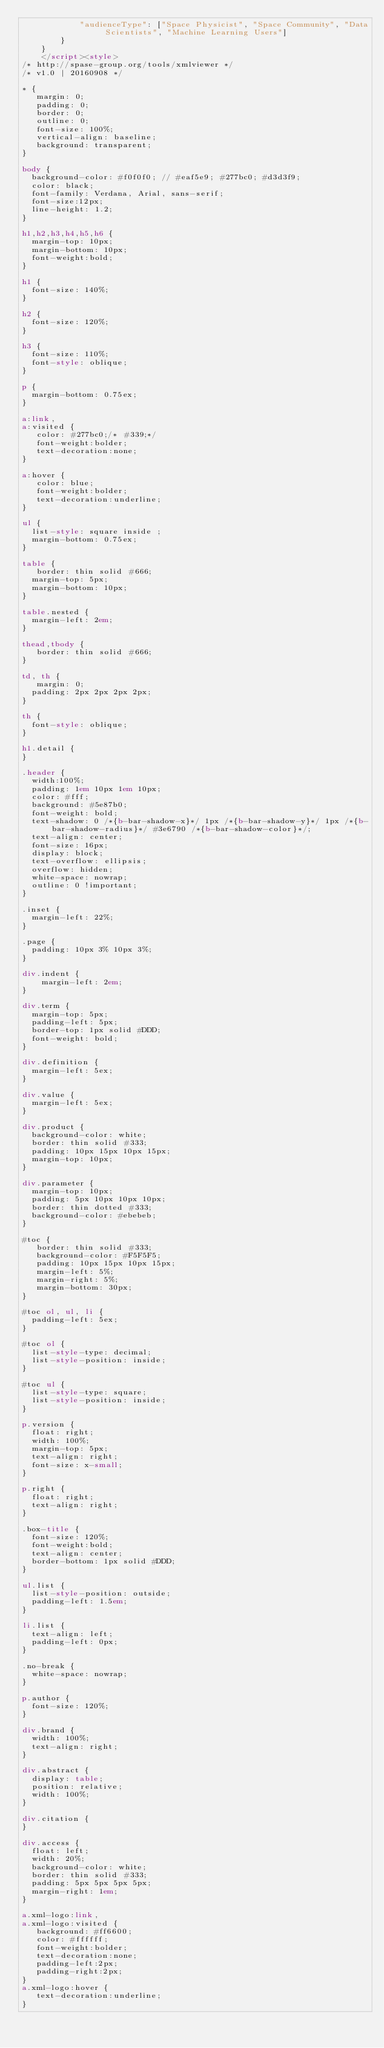<code> <loc_0><loc_0><loc_500><loc_500><_HTML_>            "audienceType": ["Space Physicist", "Space Community", "Data Scientists", "Machine Learning Users"]
        }
	  }
	  </script><style>
/* http://spase-group.org/tools/xmlviewer */
/* v1.0 | 20160908 */

* {
   margin: 0;
   padding: 0;
   border: 0;
   outline: 0;
   font-size: 100%;
   vertical-align: baseline;
   background: transparent;
}

body {
	background-color: #f0f0f0; // #eaf5e9; #277bc0; #d3d3f9;
	color: black;
	font-family: Verdana, Arial, sans-serif; 
	font-size:12px; 
	line-height: 1.2;
}
 
h1,h2,h3,h4,h5,h6 {
	margin-top: 10px;
	margin-bottom: 10px;
	font-weight:bold;
}

h1 {
	font-size: 140%;
}

h2 {
	font-size: 120%;
}

h3 {
	font-size: 110%;
	font-style: oblique;
}

p {
	margin-bottom: 0.75ex;
}

a:link,
a:visited {
   color: #277bc0;/* #339;*/
   font-weight:bolder; 
   text-decoration:none; 
}

a:hover {
   color: blue;
   font-weight:bolder; 
   text-decoration:underline; 
}

ul {
	list-style: square inside ;
	margin-bottom: 0.75ex;
}

table {
   border: thin solid #666;
	margin-top: 5px;
	margin-bottom: 10px;
}

table.nested {
	margin-left: 2em;
}

thead,tbody {
   border: thin solid #666;
}

td, th {
   margin: 0;
	padding: 2px 2px 2px 2px;
}

th {
	font-style: oblique;
}

h1.detail {
}

.header {
	width:100%;
	padding: 1em 10px 1em 10px;
	color: #fff;
	background: #5e87b0;
	font-weight: bold;
	text-shadow: 0 /*{b-bar-shadow-x}*/ 1px /*{b-bar-shadow-y}*/ 1px /*{b-bar-shadow-radius}*/ #3e6790 /*{b-bar-shadow-color}*/;
	text-align: center;
	font-size: 16px;
	display: block;
	text-overflow: ellipsis;
	overflow: hidden;
	white-space: nowrap;
	outline: 0 !important;
}

.inset {
	margin-left: 22%;
}

.page {
	padding: 10px 3% 10px 3%;
}

div.indent {
    margin-left: 2em;
}

div.term {
	margin-top: 5px;
	padding-left: 5px;
	border-top: 1px solid #DDD;
	font-weight: bold;
}

div.definition {
	margin-left: 5ex;
}

div.value {
	margin-left: 5ex;
}

div.product {
	background-color: white;
	border: thin solid #333;
	padding: 10px 15px 10px 15px;
	margin-top: 10px;
}

div.parameter {
	margin-top: 10px;
	padding: 5px 10px 10px 10px;
	border: thin dotted #333;
	background-color: #ebebeb;
}

#toc {
   border: thin solid #333;
   background-color: #F5F5F5; 
   padding: 10px 15px 10px 15px;
   margin-left: 5%;
   margin-right: 5%;
   margin-bottom: 30px;
}

#toc ol, ul, li {
	padding-left: 5ex;
}

#toc ol {
	list-style-type: decimal;
	list-style-position: inside; 
}

#toc ul {
	list-style-type: square;
	list-style-position: inside; 
}

p.version {
  float: right;
  width: 100%;
  margin-top: 5px;
  text-align: right;
  font-size: x-small;
}

p.right {
  float: right;
  text-align: right;
}

.box-title {
	font-size: 120%;
	font-weight:bold;
	text-align: center;
	border-bottom: 1px solid #DDD;
}

ul.list {
	list-style-position: outside;
	padding-left: 1.5em;
}

li.list {
	text-align: left;
	padding-left: 0px;
}

.no-break {
	white-space: nowrap;
}

p.author {
	font-size: 120%;
}

div.brand {
	width: 100%;
	text-align: right;
}

div.abstract {
	display: table;
	position: relative;
	width: 100%;
}

div.citation {
}

div.access {
	float: left;
	width: 20%;
	background-color: white;
	border: thin solid #333;
	padding: 5px 5px 5px 5px;
	margin-right: 1em;
}

a.xml-logo:link,
a.xml-logo:visited {
   background: #ff6600;
   color: #ffffff;
   font-weight:bolder; 
   text-decoration:none; 
   padding-left:2px;
   padding-right:2px;
}
a.xml-logo:hover {
   text-decoration:underline; 
}
</code> 